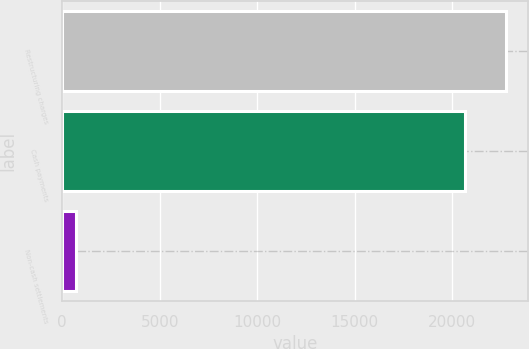<chart> <loc_0><loc_0><loc_500><loc_500><bar_chart><fcel>Restructuring charges<fcel>Cash payments<fcel>Non-cash settlements<nl><fcel>22778.8<fcel>20646<fcel>695<nl></chart> 